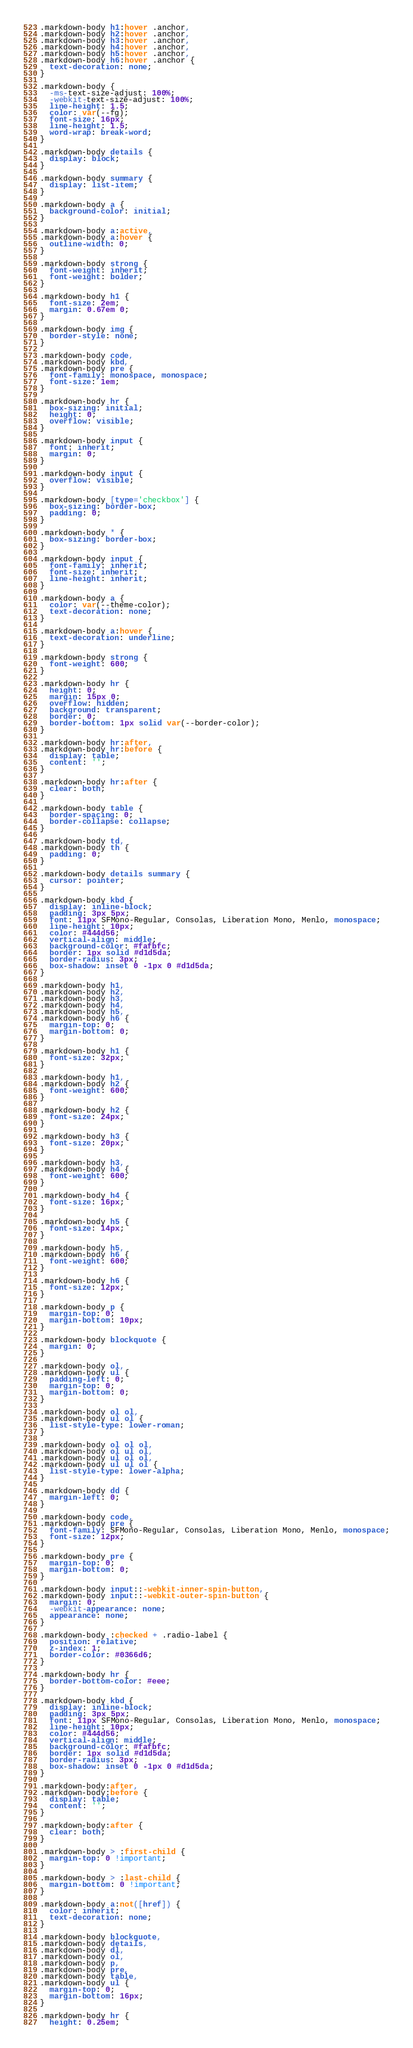Convert code to text. <code><loc_0><loc_0><loc_500><loc_500><_CSS_>.markdown-body h1:hover .anchor,
.markdown-body h2:hover .anchor,
.markdown-body h3:hover .anchor,
.markdown-body h4:hover .anchor,
.markdown-body h5:hover .anchor,
.markdown-body h6:hover .anchor {
  text-decoration: none;
}

.markdown-body {
  -ms-text-size-adjust: 100%;
  -webkit-text-size-adjust: 100%;
  line-height: 1.5;
  color: var(--fg);
  font-size: 16px;
  line-height: 1.5;
  word-wrap: break-word;
}

.markdown-body details {
  display: block;
}

.markdown-body summary {
  display: list-item;
}

.markdown-body a {
  background-color: initial;
}

.markdown-body a:active,
.markdown-body a:hover {
  outline-width: 0;
}

.markdown-body strong {
  font-weight: inherit;
  font-weight: bolder;
}

.markdown-body h1 {
  font-size: 2em;
  margin: 0.67em 0;
}

.markdown-body img {
  border-style: none;
}

.markdown-body code,
.markdown-body kbd,
.markdown-body pre {
  font-family: monospace, monospace;
  font-size: 1em;
}

.markdown-body hr {
  box-sizing: initial;
  height: 0;
  overflow: visible;
}

.markdown-body input {
  font: inherit;
  margin: 0;
}

.markdown-body input {
  overflow: visible;
}

.markdown-body [type='checkbox'] {
  box-sizing: border-box;
  padding: 0;
}

.markdown-body * {
  box-sizing: border-box;
}

.markdown-body input {
  font-family: inherit;
  font-size: inherit;
  line-height: inherit;
}

.markdown-body a {
  color: var(--theme-color);
  text-decoration: none;
}

.markdown-body a:hover {
  text-decoration: underline;
}

.markdown-body strong {
  font-weight: 600;
}

.markdown-body hr {
  height: 0;
  margin: 15px 0;
  overflow: hidden;
  background: transparent;
  border: 0;
  border-bottom: 1px solid var(--border-color);
}

.markdown-body hr:after,
.markdown-body hr:before {
  display: table;
  content: '';
}

.markdown-body hr:after {
  clear: both;
}

.markdown-body table {
  border-spacing: 0;
  border-collapse: collapse;
}

.markdown-body td,
.markdown-body th {
  padding: 0;
}

.markdown-body details summary {
  cursor: pointer;
}

.markdown-body kbd {
  display: inline-block;
  padding: 3px 5px;
  font: 11px SFMono-Regular, Consolas, Liberation Mono, Menlo, monospace;
  line-height: 10px;
  color: #444d56;
  vertical-align: middle;
  background-color: #fafbfc;
  border: 1px solid #d1d5da;
  border-radius: 3px;
  box-shadow: inset 0 -1px 0 #d1d5da;
}

.markdown-body h1,
.markdown-body h2,
.markdown-body h3,
.markdown-body h4,
.markdown-body h5,
.markdown-body h6 {
  margin-top: 0;
  margin-bottom: 0;
}

.markdown-body h1 {
  font-size: 32px;
}

.markdown-body h1,
.markdown-body h2 {
  font-weight: 600;
}

.markdown-body h2 {
  font-size: 24px;
}

.markdown-body h3 {
  font-size: 20px;
}

.markdown-body h3,
.markdown-body h4 {
  font-weight: 600;
}

.markdown-body h4 {
  font-size: 16px;
}

.markdown-body h5 {
  font-size: 14px;
}

.markdown-body h5,
.markdown-body h6 {
  font-weight: 600;
}

.markdown-body h6 {
  font-size: 12px;
}

.markdown-body p {
  margin-top: 0;
  margin-bottom: 10px;
}

.markdown-body blockquote {
  margin: 0;
}

.markdown-body ol,
.markdown-body ul {
  padding-left: 0;
  margin-top: 0;
  margin-bottom: 0;
}

.markdown-body ol ol,
.markdown-body ul ol {
  list-style-type: lower-roman;
}

.markdown-body ol ol ol,
.markdown-body ol ul ol,
.markdown-body ul ol ol,
.markdown-body ul ul ol {
  list-style-type: lower-alpha;
}

.markdown-body dd {
  margin-left: 0;
}

.markdown-body code,
.markdown-body pre {
  font-family: SFMono-Regular, Consolas, Liberation Mono, Menlo, monospace;
  font-size: 12px;
}

.markdown-body pre {
  margin-top: 0;
  margin-bottom: 0;
}

.markdown-body input::-webkit-inner-spin-button,
.markdown-body input::-webkit-outer-spin-button {
  margin: 0;
  -webkit-appearance: none;
  appearance: none;
}

.markdown-body :checked + .radio-label {
  position: relative;
  z-index: 1;
  border-color: #0366d6;
}

.markdown-body hr {
  border-bottom-color: #eee;
}

.markdown-body kbd {
  display: inline-block;
  padding: 3px 5px;
  font: 11px SFMono-Regular, Consolas, Liberation Mono, Menlo, monospace;
  line-height: 10px;
  color: #444d56;
  vertical-align: middle;
  background-color: #fafbfc;
  border: 1px solid #d1d5da;
  border-radius: 3px;
  box-shadow: inset 0 -1px 0 #d1d5da;
}

.markdown-body:after,
.markdown-body:before {
  display: table;
  content: '';
}

.markdown-body:after {
  clear: both;
}

.markdown-body > :first-child {
  margin-top: 0 !important;
}

.markdown-body > :last-child {
  margin-bottom: 0 !important;
}

.markdown-body a:not([href]) {
  color: inherit;
  text-decoration: none;
}

.markdown-body blockquote,
.markdown-body details,
.markdown-body dl,
.markdown-body ol,
.markdown-body p,
.markdown-body pre,
.markdown-body table,
.markdown-body ul {
  margin-top: 0;
  margin-bottom: 16px;
}

.markdown-body hr {
  height: 0.25em;</code> 